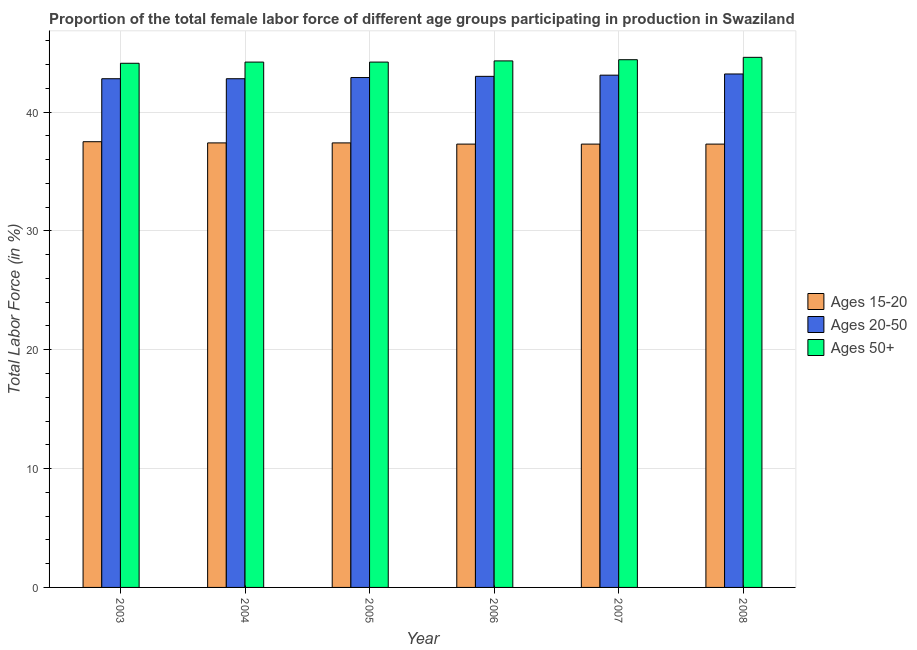How many different coloured bars are there?
Provide a short and direct response. 3. How many groups of bars are there?
Offer a very short reply. 6. Are the number of bars per tick equal to the number of legend labels?
Your response must be concise. Yes. Are the number of bars on each tick of the X-axis equal?
Offer a terse response. Yes. How many bars are there on the 5th tick from the right?
Keep it short and to the point. 3. What is the label of the 6th group of bars from the left?
Provide a succinct answer. 2008. In how many cases, is the number of bars for a given year not equal to the number of legend labels?
Your response must be concise. 0. What is the percentage of female labor force within the age group 15-20 in 2008?
Your answer should be very brief. 37.3. Across all years, what is the maximum percentage of female labor force within the age group 15-20?
Your answer should be very brief. 37.5. Across all years, what is the minimum percentage of female labor force above age 50?
Your response must be concise. 44.1. In which year was the percentage of female labor force above age 50 minimum?
Provide a succinct answer. 2003. What is the total percentage of female labor force within the age group 15-20 in the graph?
Your answer should be very brief. 224.2. What is the difference between the percentage of female labor force within the age group 20-50 in 2005 and that in 2008?
Give a very brief answer. -0.3. What is the difference between the percentage of female labor force above age 50 in 2003 and the percentage of female labor force within the age group 15-20 in 2004?
Your response must be concise. -0.1. What is the average percentage of female labor force within the age group 15-20 per year?
Give a very brief answer. 37.37. In the year 2004, what is the difference between the percentage of female labor force within the age group 15-20 and percentage of female labor force within the age group 20-50?
Ensure brevity in your answer.  0. In how many years, is the percentage of female labor force within the age group 15-20 greater than 12 %?
Keep it short and to the point. 6. What is the ratio of the percentage of female labor force within the age group 20-50 in 2004 to that in 2007?
Ensure brevity in your answer.  0.99. Is the percentage of female labor force within the age group 15-20 in 2003 less than that in 2008?
Your answer should be very brief. No. Is the difference between the percentage of female labor force within the age group 15-20 in 2007 and 2008 greater than the difference between the percentage of female labor force within the age group 20-50 in 2007 and 2008?
Your response must be concise. No. What is the difference between the highest and the second highest percentage of female labor force above age 50?
Your answer should be very brief. 0.2. What is the difference between the highest and the lowest percentage of female labor force within the age group 20-50?
Keep it short and to the point. 0.4. In how many years, is the percentage of female labor force within the age group 20-50 greater than the average percentage of female labor force within the age group 20-50 taken over all years?
Provide a short and direct response. 3. Is the sum of the percentage of female labor force above age 50 in 2007 and 2008 greater than the maximum percentage of female labor force within the age group 20-50 across all years?
Your answer should be very brief. Yes. What does the 2nd bar from the left in 2005 represents?
Provide a succinct answer. Ages 20-50. What does the 3rd bar from the right in 2005 represents?
Provide a succinct answer. Ages 15-20. Does the graph contain any zero values?
Provide a short and direct response. No. Where does the legend appear in the graph?
Ensure brevity in your answer.  Center right. How are the legend labels stacked?
Provide a short and direct response. Vertical. What is the title of the graph?
Your answer should be compact. Proportion of the total female labor force of different age groups participating in production in Swaziland. Does "Non-communicable diseases" appear as one of the legend labels in the graph?
Make the answer very short. No. What is the Total Labor Force (in %) in Ages 15-20 in 2003?
Provide a succinct answer. 37.5. What is the Total Labor Force (in %) of Ages 20-50 in 2003?
Provide a short and direct response. 42.8. What is the Total Labor Force (in %) in Ages 50+ in 2003?
Offer a terse response. 44.1. What is the Total Labor Force (in %) in Ages 15-20 in 2004?
Provide a short and direct response. 37.4. What is the Total Labor Force (in %) of Ages 20-50 in 2004?
Your answer should be compact. 42.8. What is the Total Labor Force (in %) of Ages 50+ in 2004?
Offer a terse response. 44.2. What is the Total Labor Force (in %) in Ages 15-20 in 2005?
Give a very brief answer. 37.4. What is the Total Labor Force (in %) in Ages 20-50 in 2005?
Ensure brevity in your answer.  42.9. What is the Total Labor Force (in %) of Ages 50+ in 2005?
Give a very brief answer. 44.2. What is the Total Labor Force (in %) of Ages 15-20 in 2006?
Offer a very short reply. 37.3. What is the Total Labor Force (in %) in Ages 20-50 in 2006?
Ensure brevity in your answer.  43. What is the Total Labor Force (in %) in Ages 50+ in 2006?
Keep it short and to the point. 44.3. What is the Total Labor Force (in %) in Ages 15-20 in 2007?
Provide a short and direct response. 37.3. What is the Total Labor Force (in %) in Ages 20-50 in 2007?
Provide a succinct answer. 43.1. What is the Total Labor Force (in %) in Ages 50+ in 2007?
Your response must be concise. 44.4. What is the Total Labor Force (in %) in Ages 15-20 in 2008?
Ensure brevity in your answer.  37.3. What is the Total Labor Force (in %) in Ages 20-50 in 2008?
Your answer should be compact. 43.2. What is the Total Labor Force (in %) of Ages 50+ in 2008?
Provide a succinct answer. 44.6. Across all years, what is the maximum Total Labor Force (in %) of Ages 15-20?
Keep it short and to the point. 37.5. Across all years, what is the maximum Total Labor Force (in %) in Ages 20-50?
Give a very brief answer. 43.2. Across all years, what is the maximum Total Labor Force (in %) of Ages 50+?
Your answer should be compact. 44.6. Across all years, what is the minimum Total Labor Force (in %) of Ages 15-20?
Provide a succinct answer. 37.3. Across all years, what is the minimum Total Labor Force (in %) of Ages 20-50?
Make the answer very short. 42.8. Across all years, what is the minimum Total Labor Force (in %) in Ages 50+?
Keep it short and to the point. 44.1. What is the total Total Labor Force (in %) of Ages 15-20 in the graph?
Provide a succinct answer. 224.2. What is the total Total Labor Force (in %) of Ages 20-50 in the graph?
Offer a very short reply. 257.8. What is the total Total Labor Force (in %) in Ages 50+ in the graph?
Give a very brief answer. 265.8. What is the difference between the Total Labor Force (in %) in Ages 15-20 in 2003 and that in 2004?
Your answer should be very brief. 0.1. What is the difference between the Total Labor Force (in %) of Ages 15-20 in 2003 and that in 2005?
Ensure brevity in your answer.  0.1. What is the difference between the Total Labor Force (in %) of Ages 15-20 in 2003 and that in 2006?
Offer a terse response. 0.2. What is the difference between the Total Labor Force (in %) in Ages 20-50 in 2003 and that in 2006?
Provide a short and direct response. -0.2. What is the difference between the Total Labor Force (in %) of Ages 20-50 in 2003 and that in 2007?
Keep it short and to the point. -0.3. What is the difference between the Total Labor Force (in %) of Ages 50+ in 2003 and that in 2008?
Your answer should be compact. -0.5. What is the difference between the Total Labor Force (in %) in Ages 15-20 in 2004 and that in 2005?
Give a very brief answer. 0. What is the difference between the Total Labor Force (in %) of Ages 20-50 in 2004 and that in 2006?
Your answer should be compact. -0.2. What is the difference between the Total Labor Force (in %) in Ages 15-20 in 2004 and that in 2007?
Give a very brief answer. 0.1. What is the difference between the Total Labor Force (in %) of Ages 50+ in 2004 and that in 2007?
Make the answer very short. -0.2. What is the difference between the Total Labor Force (in %) in Ages 15-20 in 2004 and that in 2008?
Ensure brevity in your answer.  0.1. What is the difference between the Total Labor Force (in %) of Ages 20-50 in 2005 and that in 2006?
Your answer should be compact. -0.1. What is the difference between the Total Labor Force (in %) in Ages 50+ in 2005 and that in 2006?
Your answer should be very brief. -0.1. What is the difference between the Total Labor Force (in %) in Ages 15-20 in 2005 and that in 2007?
Provide a succinct answer. 0.1. What is the difference between the Total Labor Force (in %) in Ages 20-50 in 2005 and that in 2007?
Offer a terse response. -0.2. What is the difference between the Total Labor Force (in %) of Ages 50+ in 2005 and that in 2007?
Give a very brief answer. -0.2. What is the difference between the Total Labor Force (in %) in Ages 20-50 in 2005 and that in 2008?
Give a very brief answer. -0.3. What is the difference between the Total Labor Force (in %) of Ages 20-50 in 2006 and that in 2007?
Keep it short and to the point. -0.1. What is the difference between the Total Labor Force (in %) in Ages 15-20 in 2006 and that in 2008?
Make the answer very short. 0. What is the difference between the Total Labor Force (in %) of Ages 20-50 in 2006 and that in 2008?
Keep it short and to the point. -0.2. What is the difference between the Total Labor Force (in %) in Ages 50+ in 2006 and that in 2008?
Your answer should be very brief. -0.3. What is the difference between the Total Labor Force (in %) in Ages 15-20 in 2007 and that in 2008?
Keep it short and to the point. 0. What is the difference between the Total Labor Force (in %) in Ages 20-50 in 2007 and that in 2008?
Provide a succinct answer. -0.1. What is the difference between the Total Labor Force (in %) in Ages 20-50 in 2003 and the Total Labor Force (in %) in Ages 50+ in 2004?
Your answer should be very brief. -1.4. What is the difference between the Total Labor Force (in %) of Ages 15-20 in 2003 and the Total Labor Force (in %) of Ages 50+ in 2005?
Keep it short and to the point. -6.7. What is the difference between the Total Labor Force (in %) in Ages 20-50 in 2003 and the Total Labor Force (in %) in Ages 50+ in 2005?
Your response must be concise. -1.4. What is the difference between the Total Labor Force (in %) of Ages 15-20 in 2003 and the Total Labor Force (in %) of Ages 20-50 in 2006?
Offer a terse response. -5.5. What is the difference between the Total Labor Force (in %) in Ages 20-50 in 2003 and the Total Labor Force (in %) in Ages 50+ in 2006?
Your answer should be very brief. -1.5. What is the difference between the Total Labor Force (in %) in Ages 15-20 in 2003 and the Total Labor Force (in %) in Ages 50+ in 2007?
Make the answer very short. -6.9. What is the difference between the Total Labor Force (in %) of Ages 20-50 in 2003 and the Total Labor Force (in %) of Ages 50+ in 2007?
Your answer should be compact. -1.6. What is the difference between the Total Labor Force (in %) of Ages 15-20 in 2003 and the Total Labor Force (in %) of Ages 20-50 in 2008?
Keep it short and to the point. -5.7. What is the difference between the Total Labor Force (in %) in Ages 20-50 in 2003 and the Total Labor Force (in %) in Ages 50+ in 2008?
Make the answer very short. -1.8. What is the difference between the Total Labor Force (in %) in Ages 15-20 in 2004 and the Total Labor Force (in %) in Ages 50+ in 2005?
Your answer should be very brief. -6.8. What is the difference between the Total Labor Force (in %) in Ages 20-50 in 2004 and the Total Labor Force (in %) in Ages 50+ in 2005?
Give a very brief answer. -1.4. What is the difference between the Total Labor Force (in %) in Ages 15-20 in 2004 and the Total Labor Force (in %) in Ages 20-50 in 2006?
Make the answer very short. -5.6. What is the difference between the Total Labor Force (in %) of Ages 15-20 in 2004 and the Total Labor Force (in %) of Ages 50+ in 2006?
Your response must be concise. -6.9. What is the difference between the Total Labor Force (in %) of Ages 20-50 in 2004 and the Total Labor Force (in %) of Ages 50+ in 2006?
Make the answer very short. -1.5. What is the difference between the Total Labor Force (in %) of Ages 15-20 in 2004 and the Total Labor Force (in %) of Ages 20-50 in 2007?
Offer a very short reply. -5.7. What is the difference between the Total Labor Force (in %) of Ages 15-20 in 2004 and the Total Labor Force (in %) of Ages 20-50 in 2008?
Keep it short and to the point. -5.8. What is the difference between the Total Labor Force (in %) of Ages 20-50 in 2004 and the Total Labor Force (in %) of Ages 50+ in 2008?
Provide a short and direct response. -1.8. What is the difference between the Total Labor Force (in %) in Ages 15-20 in 2005 and the Total Labor Force (in %) in Ages 20-50 in 2006?
Make the answer very short. -5.6. What is the difference between the Total Labor Force (in %) of Ages 15-20 in 2005 and the Total Labor Force (in %) of Ages 50+ in 2006?
Provide a succinct answer. -6.9. What is the difference between the Total Labor Force (in %) of Ages 20-50 in 2005 and the Total Labor Force (in %) of Ages 50+ in 2006?
Offer a very short reply. -1.4. What is the difference between the Total Labor Force (in %) of Ages 15-20 in 2005 and the Total Labor Force (in %) of Ages 20-50 in 2007?
Your answer should be very brief. -5.7. What is the difference between the Total Labor Force (in %) of Ages 15-20 in 2005 and the Total Labor Force (in %) of Ages 50+ in 2007?
Provide a short and direct response. -7. What is the difference between the Total Labor Force (in %) of Ages 20-50 in 2005 and the Total Labor Force (in %) of Ages 50+ in 2007?
Provide a succinct answer. -1.5. What is the difference between the Total Labor Force (in %) in Ages 15-20 in 2005 and the Total Labor Force (in %) in Ages 50+ in 2008?
Give a very brief answer. -7.2. What is the difference between the Total Labor Force (in %) of Ages 20-50 in 2005 and the Total Labor Force (in %) of Ages 50+ in 2008?
Your response must be concise. -1.7. What is the difference between the Total Labor Force (in %) of Ages 15-20 in 2006 and the Total Labor Force (in %) of Ages 20-50 in 2007?
Your response must be concise. -5.8. What is the difference between the Total Labor Force (in %) in Ages 15-20 in 2006 and the Total Labor Force (in %) in Ages 50+ in 2007?
Provide a short and direct response. -7.1. What is the difference between the Total Labor Force (in %) of Ages 20-50 in 2006 and the Total Labor Force (in %) of Ages 50+ in 2007?
Your response must be concise. -1.4. What is the difference between the Total Labor Force (in %) of Ages 15-20 in 2006 and the Total Labor Force (in %) of Ages 20-50 in 2008?
Offer a very short reply. -5.9. What is the difference between the Total Labor Force (in %) of Ages 20-50 in 2006 and the Total Labor Force (in %) of Ages 50+ in 2008?
Offer a terse response. -1.6. What is the difference between the Total Labor Force (in %) in Ages 15-20 in 2007 and the Total Labor Force (in %) in Ages 50+ in 2008?
Provide a succinct answer. -7.3. What is the difference between the Total Labor Force (in %) of Ages 20-50 in 2007 and the Total Labor Force (in %) of Ages 50+ in 2008?
Offer a very short reply. -1.5. What is the average Total Labor Force (in %) of Ages 15-20 per year?
Give a very brief answer. 37.37. What is the average Total Labor Force (in %) in Ages 20-50 per year?
Provide a succinct answer. 42.97. What is the average Total Labor Force (in %) in Ages 50+ per year?
Give a very brief answer. 44.3. In the year 2003, what is the difference between the Total Labor Force (in %) of Ages 15-20 and Total Labor Force (in %) of Ages 20-50?
Your response must be concise. -5.3. In the year 2003, what is the difference between the Total Labor Force (in %) in Ages 15-20 and Total Labor Force (in %) in Ages 50+?
Keep it short and to the point. -6.6. In the year 2003, what is the difference between the Total Labor Force (in %) of Ages 20-50 and Total Labor Force (in %) of Ages 50+?
Your answer should be compact. -1.3. In the year 2004, what is the difference between the Total Labor Force (in %) of Ages 15-20 and Total Labor Force (in %) of Ages 20-50?
Your answer should be compact. -5.4. In the year 2004, what is the difference between the Total Labor Force (in %) in Ages 20-50 and Total Labor Force (in %) in Ages 50+?
Offer a very short reply. -1.4. In the year 2005, what is the difference between the Total Labor Force (in %) of Ages 15-20 and Total Labor Force (in %) of Ages 20-50?
Provide a succinct answer. -5.5. In the year 2005, what is the difference between the Total Labor Force (in %) in Ages 15-20 and Total Labor Force (in %) in Ages 50+?
Make the answer very short. -6.8. In the year 2005, what is the difference between the Total Labor Force (in %) in Ages 20-50 and Total Labor Force (in %) in Ages 50+?
Provide a short and direct response. -1.3. In the year 2007, what is the difference between the Total Labor Force (in %) in Ages 15-20 and Total Labor Force (in %) in Ages 20-50?
Your answer should be very brief. -5.8. In the year 2007, what is the difference between the Total Labor Force (in %) of Ages 20-50 and Total Labor Force (in %) of Ages 50+?
Offer a terse response. -1.3. In the year 2008, what is the difference between the Total Labor Force (in %) in Ages 15-20 and Total Labor Force (in %) in Ages 20-50?
Ensure brevity in your answer.  -5.9. In the year 2008, what is the difference between the Total Labor Force (in %) in Ages 15-20 and Total Labor Force (in %) in Ages 50+?
Provide a succinct answer. -7.3. What is the ratio of the Total Labor Force (in %) of Ages 15-20 in 2003 to that in 2004?
Make the answer very short. 1. What is the ratio of the Total Labor Force (in %) of Ages 20-50 in 2003 to that in 2004?
Your answer should be very brief. 1. What is the ratio of the Total Labor Force (in %) in Ages 50+ in 2003 to that in 2004?
Give a very brief answer. 1. What is the ratio of the Total Labor Force (in %) of Ages 20-50 in 2003 to that in 2005?
Offer a very short reply. 1. What is the ratio of the Total Labor Force (in %) of Ages 15-20 in 2003 to that in 2006?
Provide a short and direct response. 1.01. What is the ratio of the Total Labor Force (in %) of Ages 50+ in 2003 to that in 2006?
Your answer should be very brief. 1. What is the ratio of the Total Labor Force (in %) in Ages 15-20 in 2003 to that in 2007?
Your response must be concise. 1.01. What is the ratio of the Total Labor Force (in %) in Ages 50+ in 2003 to that in 2007?
Give a very brief answer. 0.99. What is the ratio of the Total Labor Force (in %) of Ages 15-20 in 2003 to that in 2008?
Your response must be concise. 1.01. What is the ratio of the Total Labor Force (in %) in Ages 20-50 in 2003 to that in 2008?
Your response must be concise. 0.99. What is the ratio of the Total Labor Force (in %) in Ages 50+ in 2003 to that in 2008?
Offer a terse response. 0.99. What is the ratio of the Total Labor Force (in %) in Ages 50+ in 2004 to that in 2005?
Make the answer very short. 1. What is the ratio of the Total Labor Force (in %) in Ages 15-20 in 2004 to that in 2006?
Offer a very short reply. 1. What is the ratio of the Total Labor Force (in %) of Ages 20-50 in 2004 to that in 2007?
Offer a very short reply. 0.99. What is the ratio of the Total Labor Force (in %) in Ages 50+ in 2004 to that in 2007?
Your answer should be compact. 1. What is the ratio of the Total Labor Force (in %) of Ages 15-20 in 2004 to that in 2008?
Make the answer very short. 1. What is the ratio of the Total Labor Force (in %) in Ages 50+ in 2004 to that in 2008?
Give a very brief answer. 0.99. What is the ratio of the Total Labor Force (in %) in Ages 15-20 in 2005 to that in 2006?
Make the answer very short. 1. What is the ratio of the Total Labor Force (in %) in Ages 50+ in 2005 to that in 2008?
Your answer should be very brief. 0.99. What is the ratio of the Total Labor Force (in %) of Ages 15-20 in 2006 to that in 2007?
Offer a very short reply. 1. What is the ratio of the Total Labor Force (in %) of Ages 20-50 in 2006 to that in 2007?
Give a very brief answer. 1. What is the ratio of the Total Labor Force (in %) of Ages 15-20 in 2006 to that in 2008?
Ensure brevity in your answer.  1. What is the ratio of the Total Labor Force (in %) in Ages 50+ in 2006 to that in 2008?
Make the answer very short. 0.99. What is the ratio of the Total Labor Force (in %) in Ages 20-50 in 2007 to that in 2008?
Your answer should be very brief. 1. What is the ratio of the Total Labor Force (in %) in Ages 50+ in 2007 to that in 2008?
Offer a very short reply. 1. What is the difference between the highest and the second highest Total Labor Force (in %) in Ages 15-20?
Keep it short and to the point. 0.1. What is the difference between the highest and the lowest Total Labor Force (in %) in Ages 20-50?
Your response must be concise. 0.4. What is the difference between the highest and the lowest Total Labor Force (in %) in Ages 50+?
Your answer should be very brief. 0.5. 